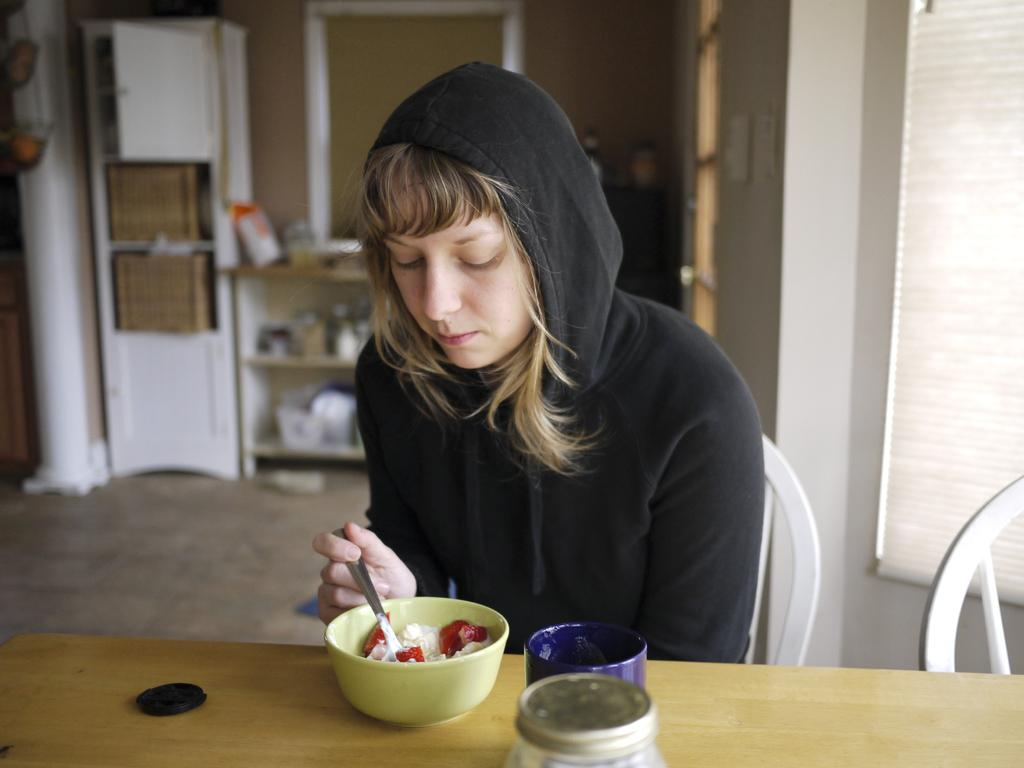Who is the main subject in the image? There is a woman in the image. What is the woman doing in the image? The woman is sitting on a chair. What is the woman holding in the image? The woman is holding a spoon. What is the woman wearing in the image? The woman is wearing a sweater. What type of debt is the woman discussing with the goat in the image? There is no goat present in the image, and therefore no discussion about debt can be observed. 